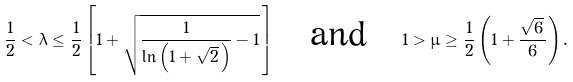<formula> <loc_0><loc_0><loc_500><loc_500>\frac { 1 } { 2 } < \lambda \leq \frac { 1 } { 2 } \left [ 1 + \sqrt { \frac { 1 } { \ln \left ( 1 + \sqrt { 2 } \, \right ) } - 1 } \, \right ] \quad \text {and} \quad 1 > \mu \geq \frac { 1 } { 2 } \left ( 1 + \frac { \sqrt { 6 } \, } 6 \right ) .</formula> 